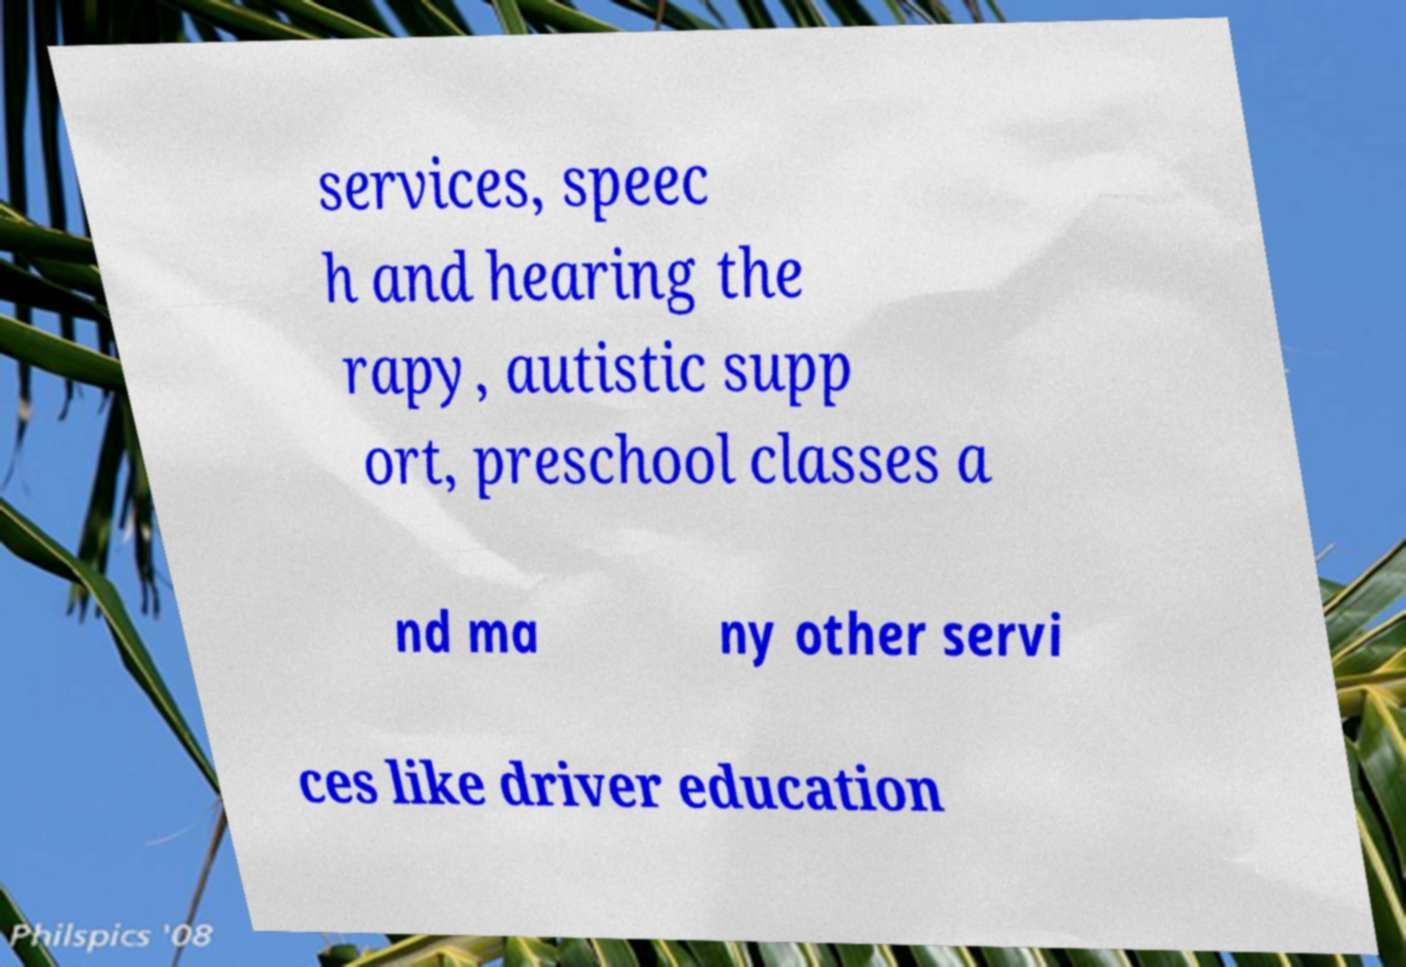Please identify and transcribe the text found in this image. services, speec h and hearing the rapy, autistic supp ort, preschool classes a nd ma ny other servi ces like driver education 